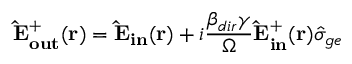Convert formula to latex. <formula><loc_0><loc_0><loc_500><loc_500>{ \hat { E } _ { o u t } ^ { + } ( { r } ) } = { \hat { E } _ { i n } ( { r } ) } + i \frac { \beta _ { d i r } \gamma } { \Omega } { \hat { E } _ { i n } ^ { + } ( { r } ) } \hat { \sigma } _ { g e }</formula> 